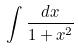<formula> <loc_0><loc_0><loc_500><loc_500>\int \frac { d x } { 1 + x ^ { 2 } }</formula> 